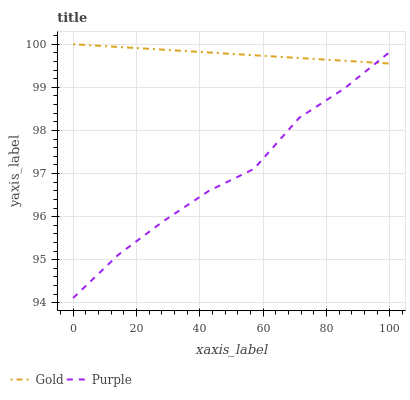Does Purple have the minimum area under the curve?
Answer yes or no. Yes. Does Gold have the maximum area under the curve?
Answer yes or no. Yes. Does Gold have the minimum area under the curve?
Answer yes or no. No. Is Gold the smoothest?
Answer yes or no. Yes. Is Purple the roughest?
Answer yes or no. Yes. Is Gold the roughest?
Answer yes or no. No. Does Purple have the lowest value?
Answer yes or no. Yes. Does Gold have the lowest value?
Answer yes or no. No. Does Gold have the highest value?
Answer yes or no. Yes. Does Gold intersect Purple?
Answer yes or no. Yes. Is Gold less than Purple?
Answer yes or no. No. Is Gold greater than Purple?
Answer yes or no. No. 